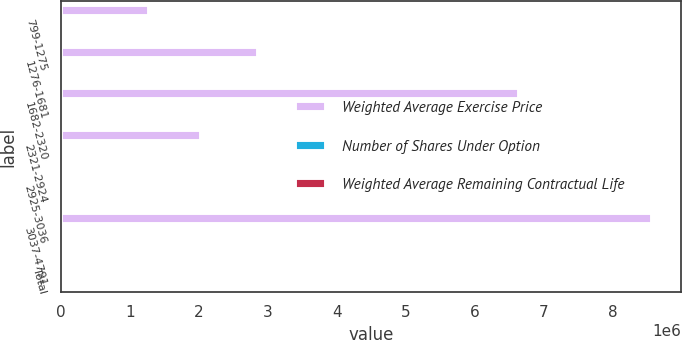Convert chart. <chart><loc_0><loc_0><loc_500><loc_500><stacked_bar_chart><ecel><fcel>799-1275<fcel>1276-1681<fcel>1682-2320<fcel>2321-2924<fcel>2925-3036<fcel>3037-4791<fcel>Total<nl><fcel>Weighted Average Exercise Price<fcel>1.27274e+06<fcel>2.85059e+06<fcel>6.64227e+06<fcel>2.0214e+06<fcel>22388<fcel>8.56132e+06<fcel>21.26<nl><fcel>Number of Shares Under Option<fcel>2<fcel>5<fcel>8<fcel>4<fcel>7<fcel>7<fcel>6<nl><fcel>Weighted Average Remaining Contractual Life<fcel>10.23<fcel>15.21<fcel>18.6<fcel>23.92<fcel>29.56<fcel>34.2<fcel>24.41<nl></chart> 